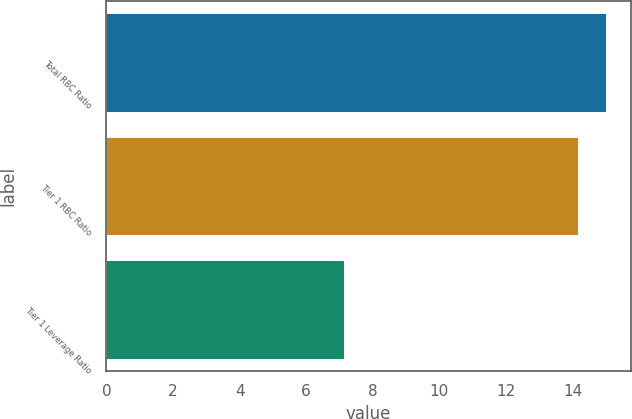Convert chart. <chart><loc_0><loc_0><loc_500><loc_500><bar_chart><fcel>Total RBC Ratio<fcel>Tier 1 RBC Ratio<fcel>Tier 1 Leverage Ratio<nl><fcel>15<fcel>14.16<fcel>7.14<nl></chart> 